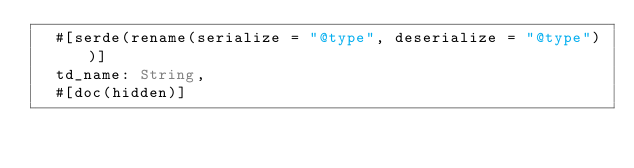Convert code to text. <code><loc_0><loc_0><loc_500><loc_500><_Rust_>  #[serde(rename(serialize = "@type", deserialize = "@type"))]
  td_name: String,
  #[doc(hidden)]</code> 